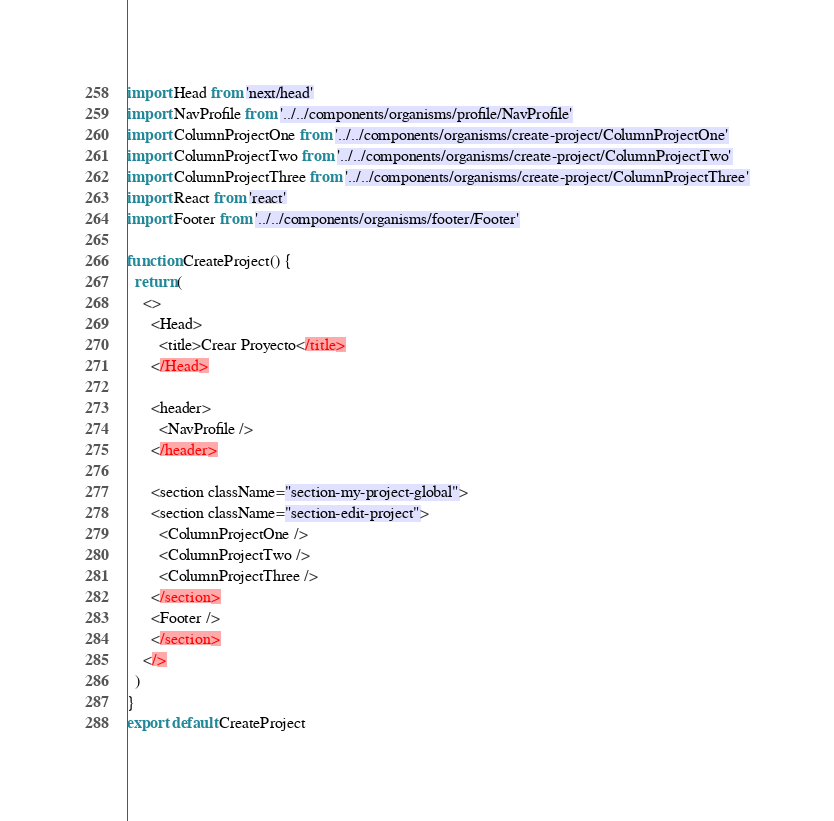Convert code to text. <code><loc_0><loc_0><loc_500><loc_500><_TypeScript_>import Head from 'next/head'
import NavProfile from '../../components/organisms/profile/NavProfile'
import ColumnProjectOne from '../../components/organisms/create-project/ColumnProjectOne'
import ColumnProjectTwo from '../../components/organisms/create-project/ColumnProjectTwo'
import ColumnProjectThree from '../../components/organisms/create-project/ColumnProjectThree'
import React from 'react'
import Footer from '../../components/organisms/footer/Footer'

function CreateProject() {
  return (
    <>
      <Head>
        <title>Crear Proyecto</title>
      </Head>

      <header>
        <NavProfile />
      </header>

      <section className="section-my-project-global">
      <section className="section-edit-project">
        <ColumnProjectOne />
        <ColumnProjectTwo />
        <ColumnProjectThree />
      </section>
      <Footer />
      </section>
    </>
  )
}
export default CreateProject
</code> 